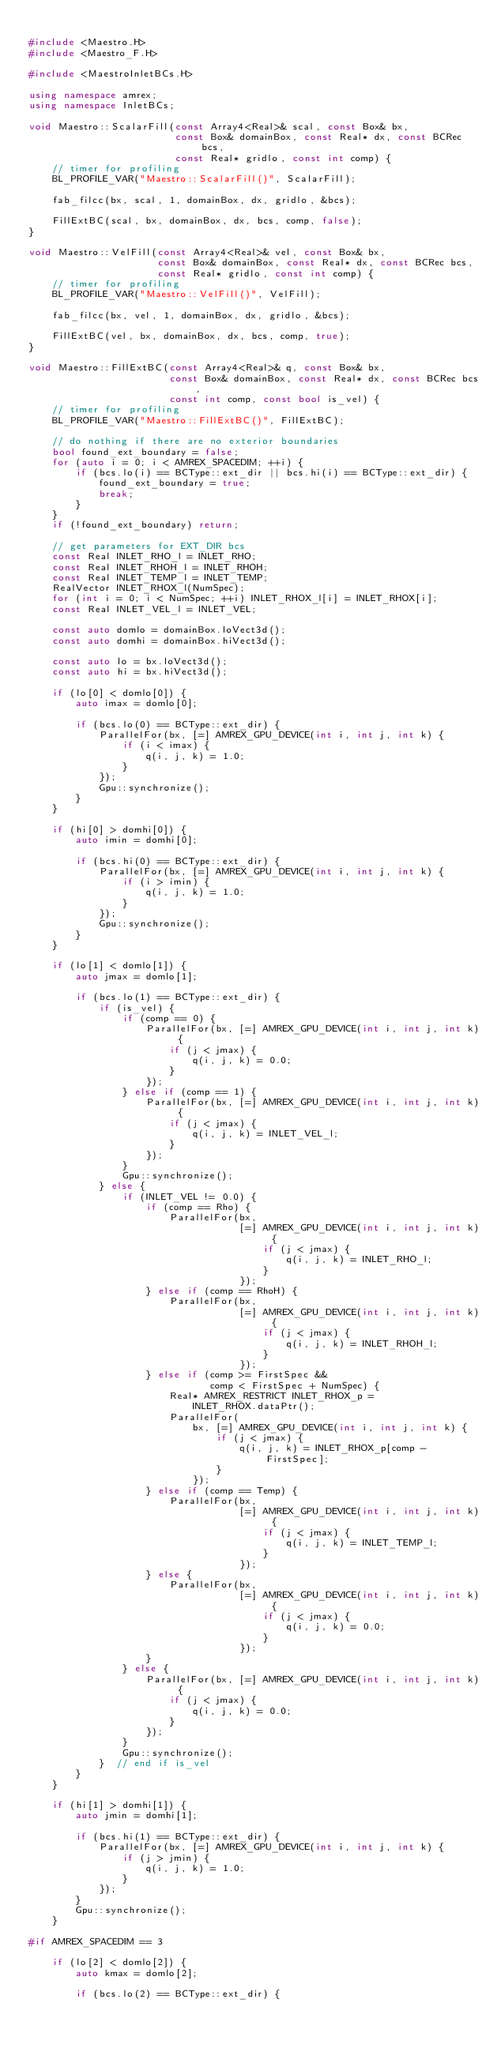Convert code to text. <code><loc_0><loc_0><loc_500><loc_500><_C++_>
#include <Maestro.H>
#include <Maestro_F.H>

#include <MaestroInletBCs.H>

using namespace amrex;
using namespace InletBCs;

void Maestro::ScalarFill(const Array4<Real>& scal, const Box& bx,
                         const Box& domainBox, const Real* dx, const BCRec bcs,
                         const Real* gridlo, const int comp) {
    // timer for profiling
    BL_PROFILE_VAR("Maestro::ScalarFill()", ScalarFill);

    fab_filcc(bx, scal, 1, domainBox, dx, gridlo, &bcs);

    FillExtBC(scal, bx, domainBox, dx, bcs, comp, false);
}

void Maestro::VelFill(const Array4<Real>& vel, const Box& bx,
                      const Box& domainBox, const Real* dx, const BCRec bcs,
                      const Real* gridlo, const int comp) {
    // timer for profiling
    BL_PROFILE_VAR("Maestro::VelFill()", VelFill);

    fab_filcc(bx, vel, 1, domainBox, dx, gridlo, &bcs);

    FillExtBC(vel, bx, domainBox, dx, bcs, comp, true);
}

void Maestro::FillExtBC(const Array4<Real>& q, const Box& bx,
                        const Box& domainBox, const Real* dx, const BCRec bcs,
                        const int comp, const bool is_vel) {
    // timer for profiling
    BL_PROFILE_VAR("Maestro::FillExtBC()", FillExtBC);

    // do nothing if there are no exterior boundaries
    bool found_ext_boundary = false;
    for (auto i = 0; i < AMREX_SPACEDIM; ++i) {
        if (bcs.lo(i) == BCType::ext_dir || bcs.hi(i) == BCType::ext_dir) {
            found_ext_boundary = true;
            break;
        }
    }
    if (!found_ext_boundary) return;

    // get parameters for EXT_DIR bcs
    const Real INLET_RHO_l = INLET_RHO;
    const Real INLET_RHOH_l = INLET_RHOH;
    const Real INLET_TEMP_l = INLET_TEMP;
    RealVector INLET_RHOX_l(NumSpec);
    for (int i = 0; i < NumSpec; ++i) INLET_RHOX_l[i] = INLET_RHOX[i];
    const Real INLET_VEL_l = INLET_VEL;

    const auto domlo = domainBox.loVect3d();
    const auto domhi = domainBox.hiVect3d();

    const auto lo = bx.loVect3d();
    const auto hi = bx.hiVect3d();

    if (lo[0] < domlo[0]) {
        auto imax = domlo[0];

        if (bcs.lo(0) == BCType::ext_dir) {
            ParallelFor(bx, [=] AMREX_GPU_DEVICE(int i, int j, int k) {
                if (i < imax) {
                    q(i, j, k) = 1.0;
                }
            });
            Gpu::synchronize();
        }
    }

    if (hi[0] > domhi[0]) {
        auto imin = domhi[0];

        if (bcs.hi(0) == BCType::ext_dir) {
            ParallelFor(bx, [=] AMREX_GPU_DEVICE(int i, int j, int k) {
                if (i > imin) {
                    q(i, j, k) = 1.0;
                }
            });
            Gpu::synchronize();
        }
    }

    if (lo[1] < domlo[1]) {
        auto jmax = domlo[1];

        if (bcs.lo(1) == BCType::ext_dir) {
            if (is_vel) {
                if (comp == 0) {
                    ParallelFor(bx, [=] AMREX_GPU_DEVICE(int i, int j, int k) {
                        if (j < jmax) {
                            q(i, j, k) = 0.0;
                        }
                    });
                } else if (comp == 1) {
                    ParallelFor(bx, [=] AMREX_GPU_DEVICE(int i, int j, int k) {
                        if (j < jmax) {
                            q(i, j, k) = INLET_VEL_l;
                        }
                    });
                }
                Gpu::synchronize();
            } else {
                if (INLET_VEL != 0.0) {
                    if (comp == Rho) {
                        ParallelFor(bx,
                                    [=] AMREX_GPU_DEVICE(int i, int j, int k) {
                                        if (j < jmax) {
                                            q(i, j, k) = INLET_RHO_l;
                                        }
                                    });
                    } else if (comp == RhoH) {
                        ParallelFor(bx,
                                    [=] AMREX_GPU_DEVICE(int i, int j, int k) {
                                        if (j < jmax) {
                                            q(i, j, k) = INLET_RHOH_l;
                                        }
                                    });
                    } else if (comp >= FirstSpec &&
                               comp < FirstSpec + NumSpec) {
                        Real* AMREX_RESTRICT INLET_RHOX_p =
                            INLET_RHOX.dataPtr();
                        ParallelFor(
                            bx, [=] AMREX_GPU_DEVICE(int i, int j, int k) {
                                if (j < jmax) {
                                    q(i, j, k) = INLET_RHOX_p[comp - FirstSpec];
                                }
                            });
                    } else if (comp == Temp) {
                        ParallelFor(bx,
                                    [=] AMREX_GPU_DEVICE(int i, int j, int k) {
                                        if (j < jmax) {
                                            q(i, j, k) = INLET_TEMP_l;
                                        }
                                    });
                    } else {
                        ParallelFor(bx,
                                    [=] AMREX_GPU_DEVICE(int i, int j, int k) {
                                        if (j < jmax) {
                                            q(i, j, k) = 0.0;
                                        }
                                    });
                    }
                } else {
                    ParallelFor(bx, [=] AMREX_GPU_DEVICE(int i, int j, int k) {
                        if (j < jmax) {
                            q(i, j, k) = 0.0;
                        }
                    });
                }
                Gpu::synchronize();
            }  // end if is_vel
        }
    }

    if (hi[1] > domhi[1]) {
        auto jmin = domhi[1];

        if (bcs.hi(1) == BCType::ext_dir) {
            ParallelFor(bx, [=] AMREX_GPU_DEVICE(int i, int j, int k) {
                if (j > jmin) {
                    q(i, j, k) = 1.0;
                }
            });
        }
        Gpu::synchronize();
    }

#if AMREX_SPACEDIM == 3

    if (lo[2] < domlo[2]) {
        auto kmax = domlo[2];

        if (bcs.lo(2) == BCType::ext_dir) {</code> 